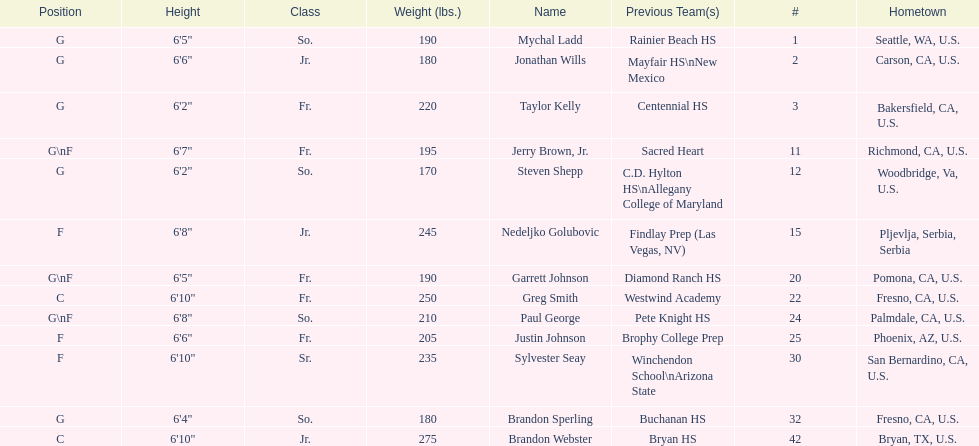Which player previously played for sacred heart? Jerry Brown, Jr. 